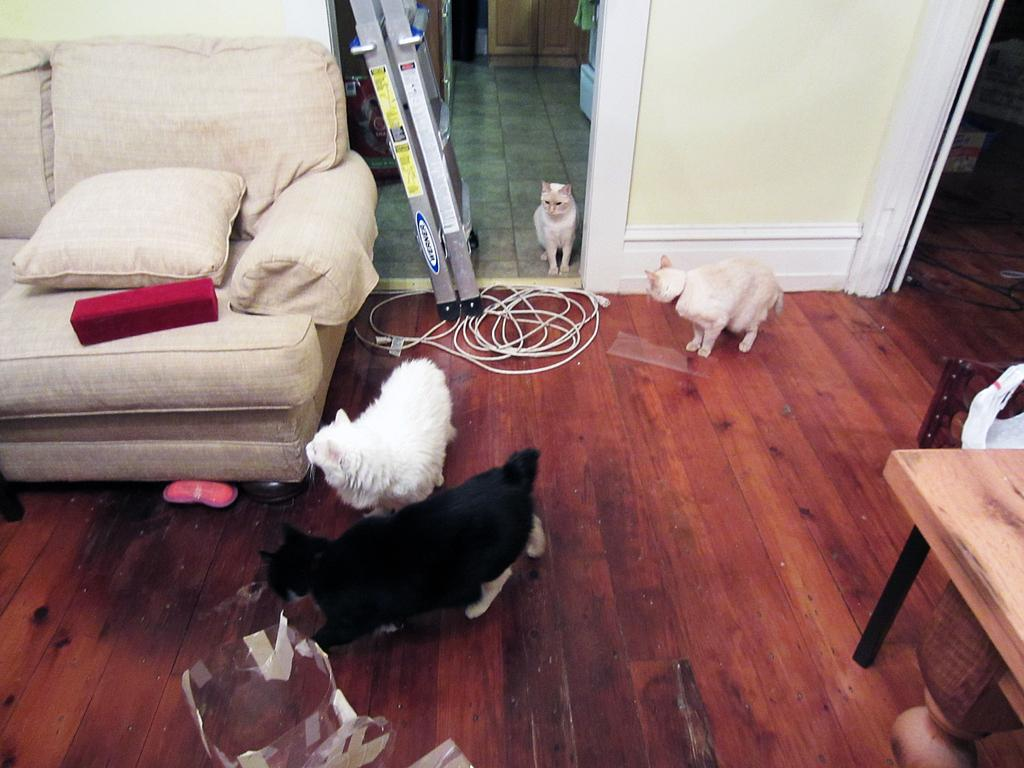What type of furniture is present in the image? There is a sofa in the image. How many cats can be seen in the image? There are four cats in the image. What other piece of furniture is visible in the image? There is a table in the image. Is there a branch visible in the image? There is no branch present in the image. Can you see a person interacting with the cats in the image? There is no person visible in the image; only the sofa, table, and four cats are present. 